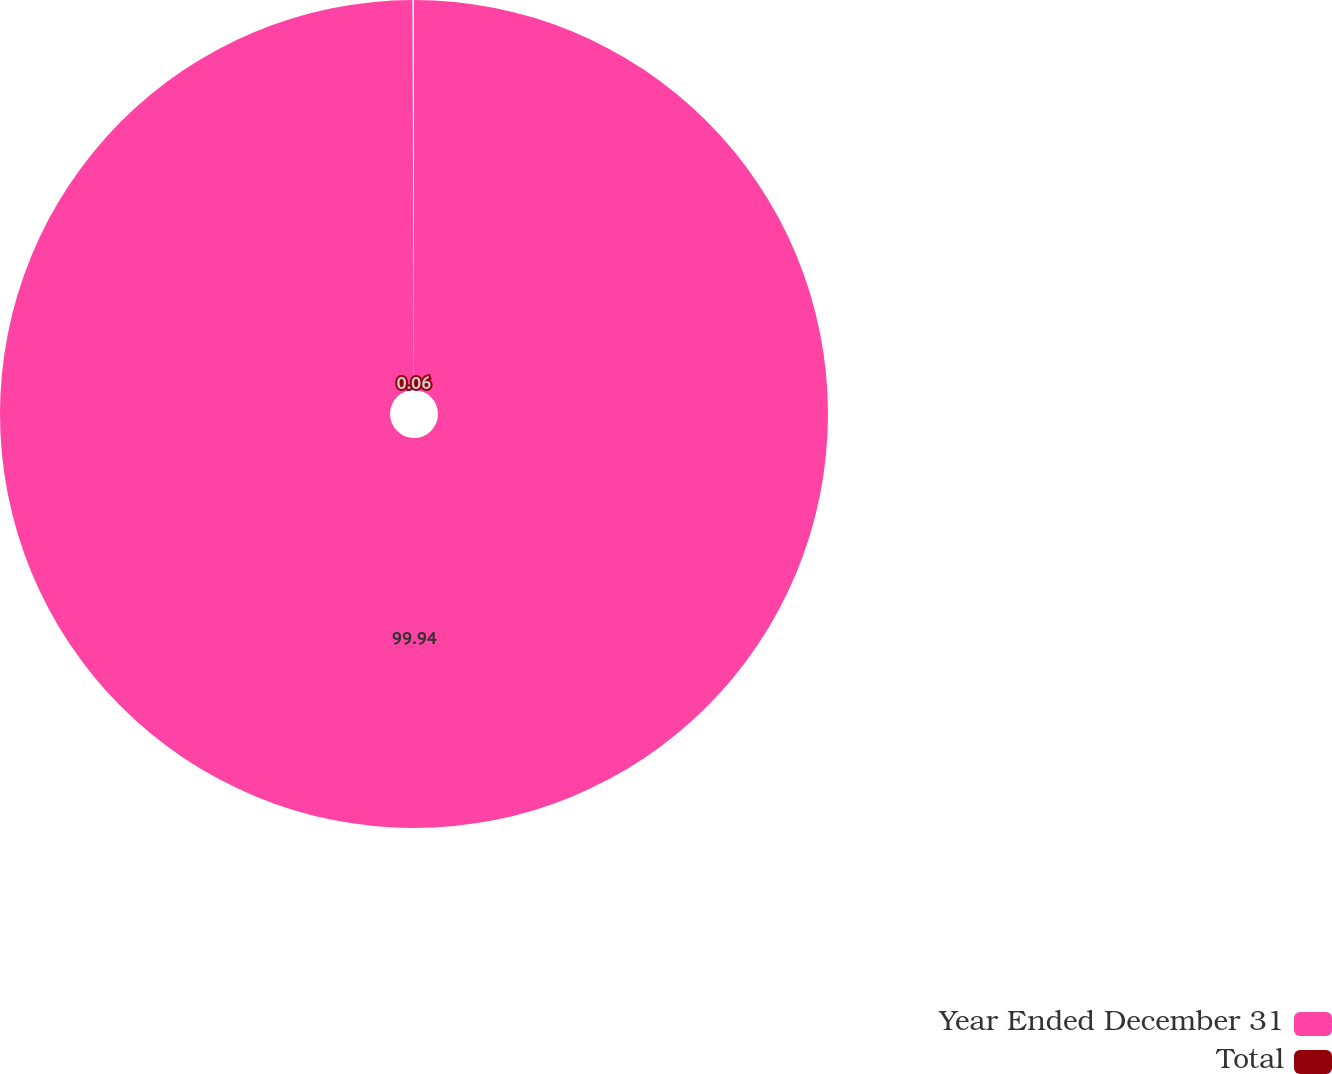Convert chart to OTSL. <chart><loc_0><loc_0><loc_500><loc_500><pie_chart><fcel>Year Ended December 31<fcel>Total<nl><fcel>99.94%<fcel>0.06%<nl></chart> 